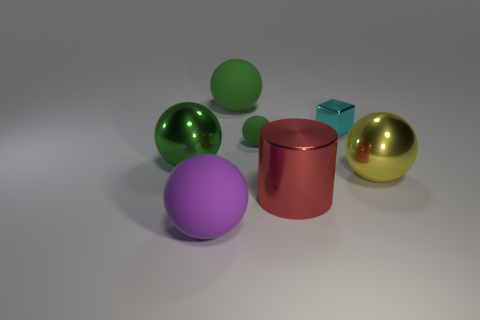Is there any other thing that has the same shape as the yellow shiny object?
Your answer should be very brief. Yes. Is the shape of the big purple object the same as the big yellow metallic object?
Make the answer very short. Yes. Are there an equal number of metal cylinders behind the large yellow shiny thing and big purple things right of the purple ball?
Your answer should be compact. Yes. What number of other objects are the same material as the big purple ball?
Make the answer very short. 2. What number of small objects are either red metal things or blue shiny objects?
Offer a terse response. 0. Are there the same number of big yellow spheres that are left of the big green matte thing and tiny yellow rubber cubes?
Provide a short and direct response. Yes. Are there any yellow shiny things that are in front of the large rubber sphere that is in front of the tiny rubber sphere?
Provide a succinct answer. No. How many other things are the same color as the cylinder?
Your answer should be very brief. 0. The tiny metal block is what color?
Your response must be concise. Cyan. How big is the matte thing that is both behind the purple thing and in front of the small cyan object?
Your answer should be compact. Small. 